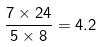<formula> <loc_0><loc_0><loc_500><loc_500>\frac { 7 \times 2 4 } { 5 \times 8 } = 4 . 2</formula> 